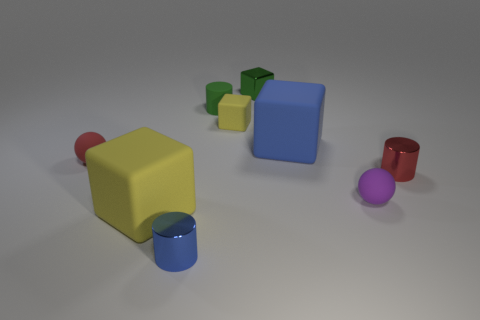What number of objects are the same color as the tiny shiny block?
Keep it short and to the point. 1. Is the number of big blue objects left of the small rubber block the same as the number of brown rubber balls?
Keep it short and to the point. Yes. Does the green rubber cylinder have the same size as the red rubber object?
Provide a succinct answer. Yes. There is a small red object on the right side of the metallic object that is to the left of the small yellow matte block; are there any big rubber things that are behind it?
Make the answer very short. Yes. There is a large yellow thing that is the same shape as the tiny yellow object; what material is it?
Keep it short and to the point. Rubber. How many tiny green matte things are behind the tiny ball that is on the right side of the big blue rubber object?
Your response must be concise. 1. There is a yellow matte block that is behind the yellow thing that is on the left side of the yellow rubber thing behind the red ball; how big is it?
Provide a succinct answer. Small. The tiny sphere to the right of the metallic cylinder left of the purple object is what color?
Offer a very short reply. Purple. What number of other objects are the same material as the small blue object?
Your answer should be compact. 2. There is a red thing right of the tiny rubber object in front of the red metal cylinder; what is it made of?
Offer a terse response. Metal. 